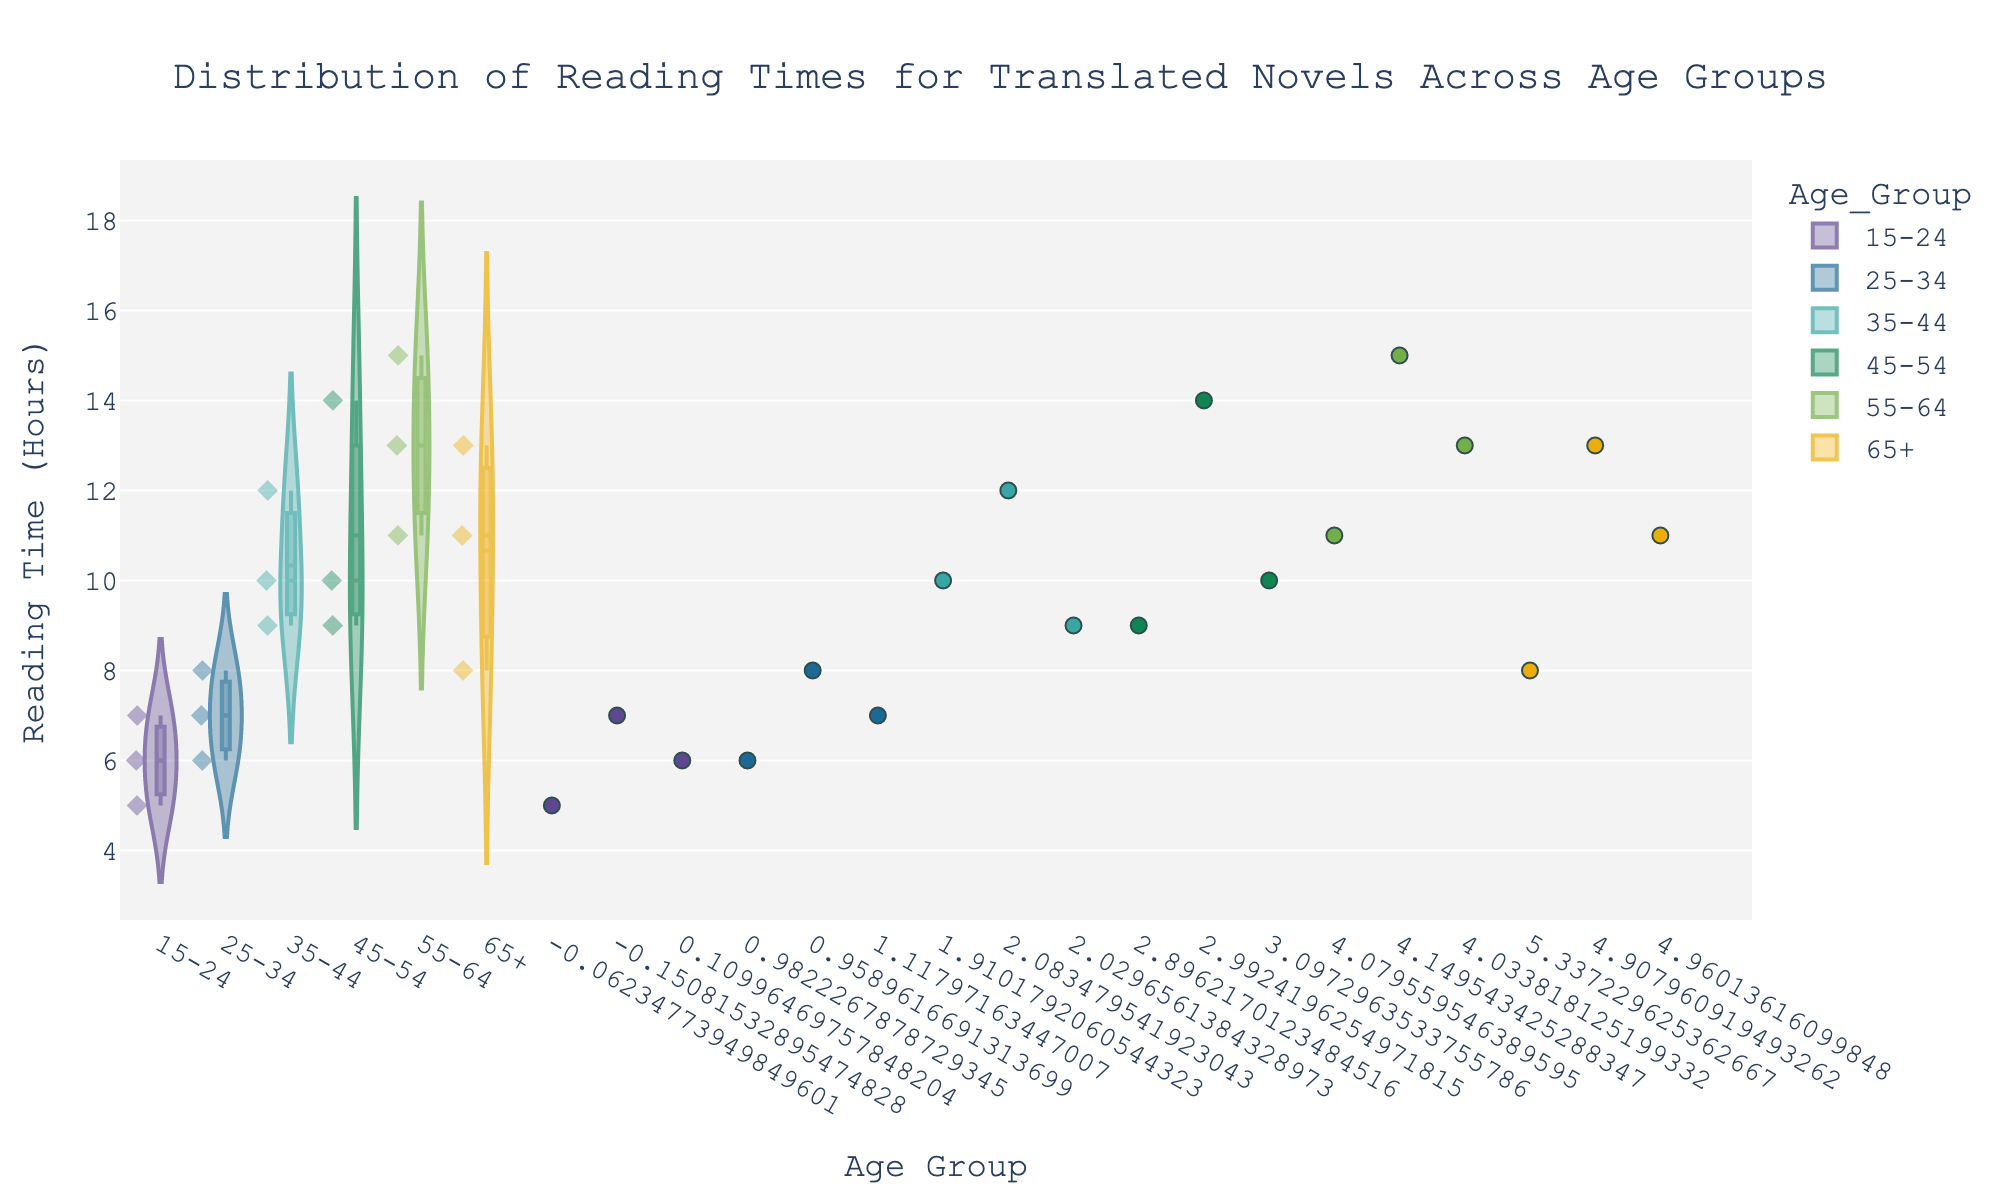What is the title of the chart? The title of the chart is displayed prominently at the top. It reads "Distribution of Reading Times for Translated Novels Across Age Groups".
Answer: Distribution of Reading Times for Translated Novels Across Age Groups How many age groups are represented in the chart? The x-axis labels show the different age groups. There are six distinct age groups labeled: 15-24, 25-34, 35-44, 45-54, 55-64, and 65+.
Answer: 6 Which age group has the longest reading time for a single novel? Looking at the y-axis, the 45-54 age group has the longest reading time with a single point reaching up to 14 hours.
Answer: 45-54 What is the median reading time for the 25-34 age group? The median reading time is indicated by a line within the box part of the violin plot. For the 25-34 age group, the median reading time is at 7 hours.
Answer: 7 hours How do the ranges of reading times compare between the 35-44 and 65+ age groups? The range for the 35-44 age group spans from about 9 to 12 hours, whereas the 65+ age group spans from 8 to 13 hours. The 35-44 group has a narrower range (3 hours), and the 65+ group has a broader range (5 hours).
Answer: 65+ has a broader range Which age group shows the widest variance in reading times? By observing the spread of the points and the shape of the violin plots, the 45-54 age group has the widest variance, with points ranging from 9 to 14 hours.
Answer: 45-54 Are there any age groups where all reading times are below 10 hours? Checking the points and violin plots for each age group, only the 15-24 age group has all reading times below 10 hours.
Answer: 15-24 Which age group has the highest average reading time? The average reading time can be inferred from the position of the bulk of the data points and the shape of the violin plots. The 55-64 age group appears to have the highest average, with most points clustering around 11-15 hours.
Answer: 55-64 What is the mean reading time for novels in the 35-44 age group? The mean reading time is shown by the dashed line within the violin plot. In the 35-44 age group, the mean reading time is around 10 hours.
Answer: 10 hours 